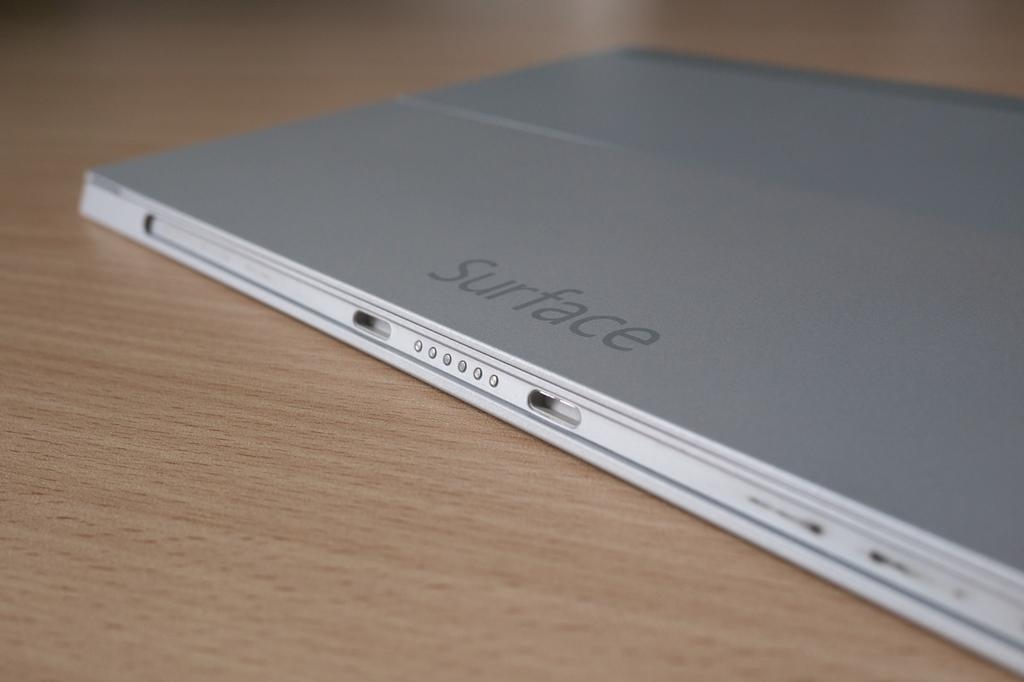What object in the image can be considered a gadget? There is a gadget in the image. Where is the gadget located in the image? The gadget is kept on a table. What type of lace can be seen decorating the gadget in the image? There is no lace present on the gadget in the image. What type of yak is visible in the image? There is no yak present in the image. 